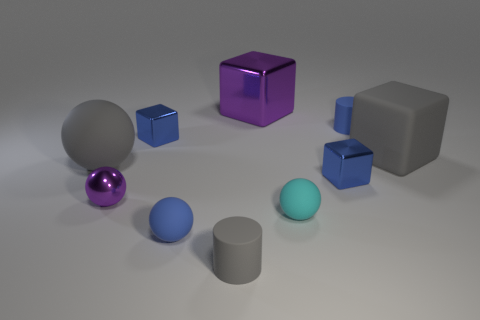What can you say about the lighting of this scene? The scene is softly lit from above, casting gentle shadows beneath each object and giving the objects a matte finish. The source of light seems to be diffused, likely an overhead source given the shadow placement. 